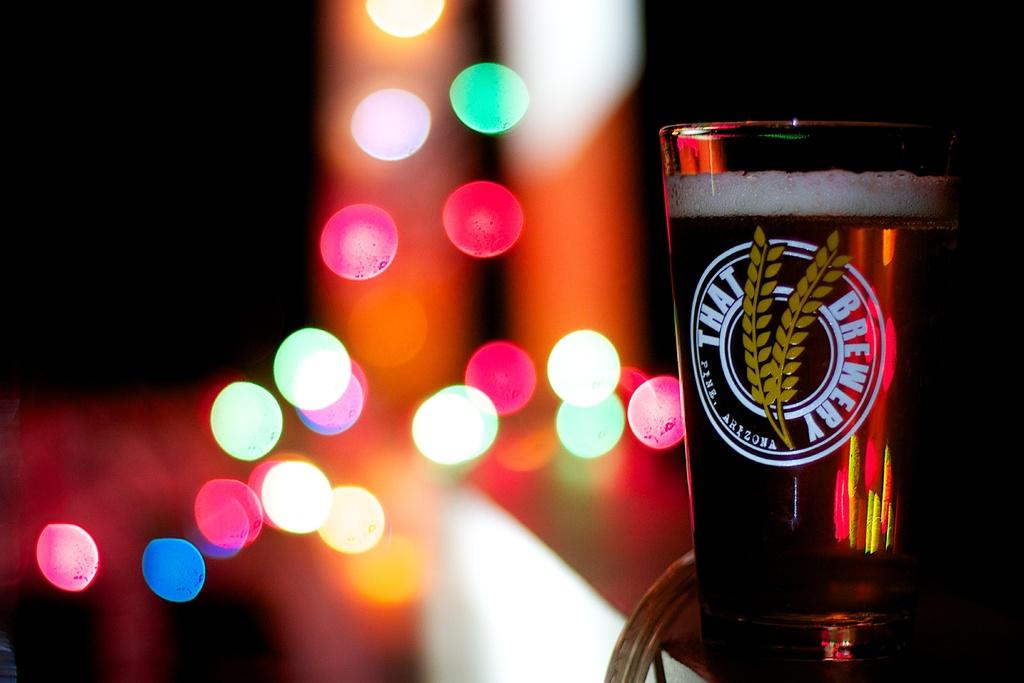<image>
Share a concise interpretation of the image provided. A beer glass with advertises That Brewery that is filled with beer. 